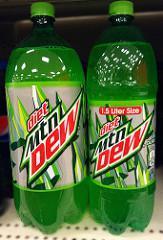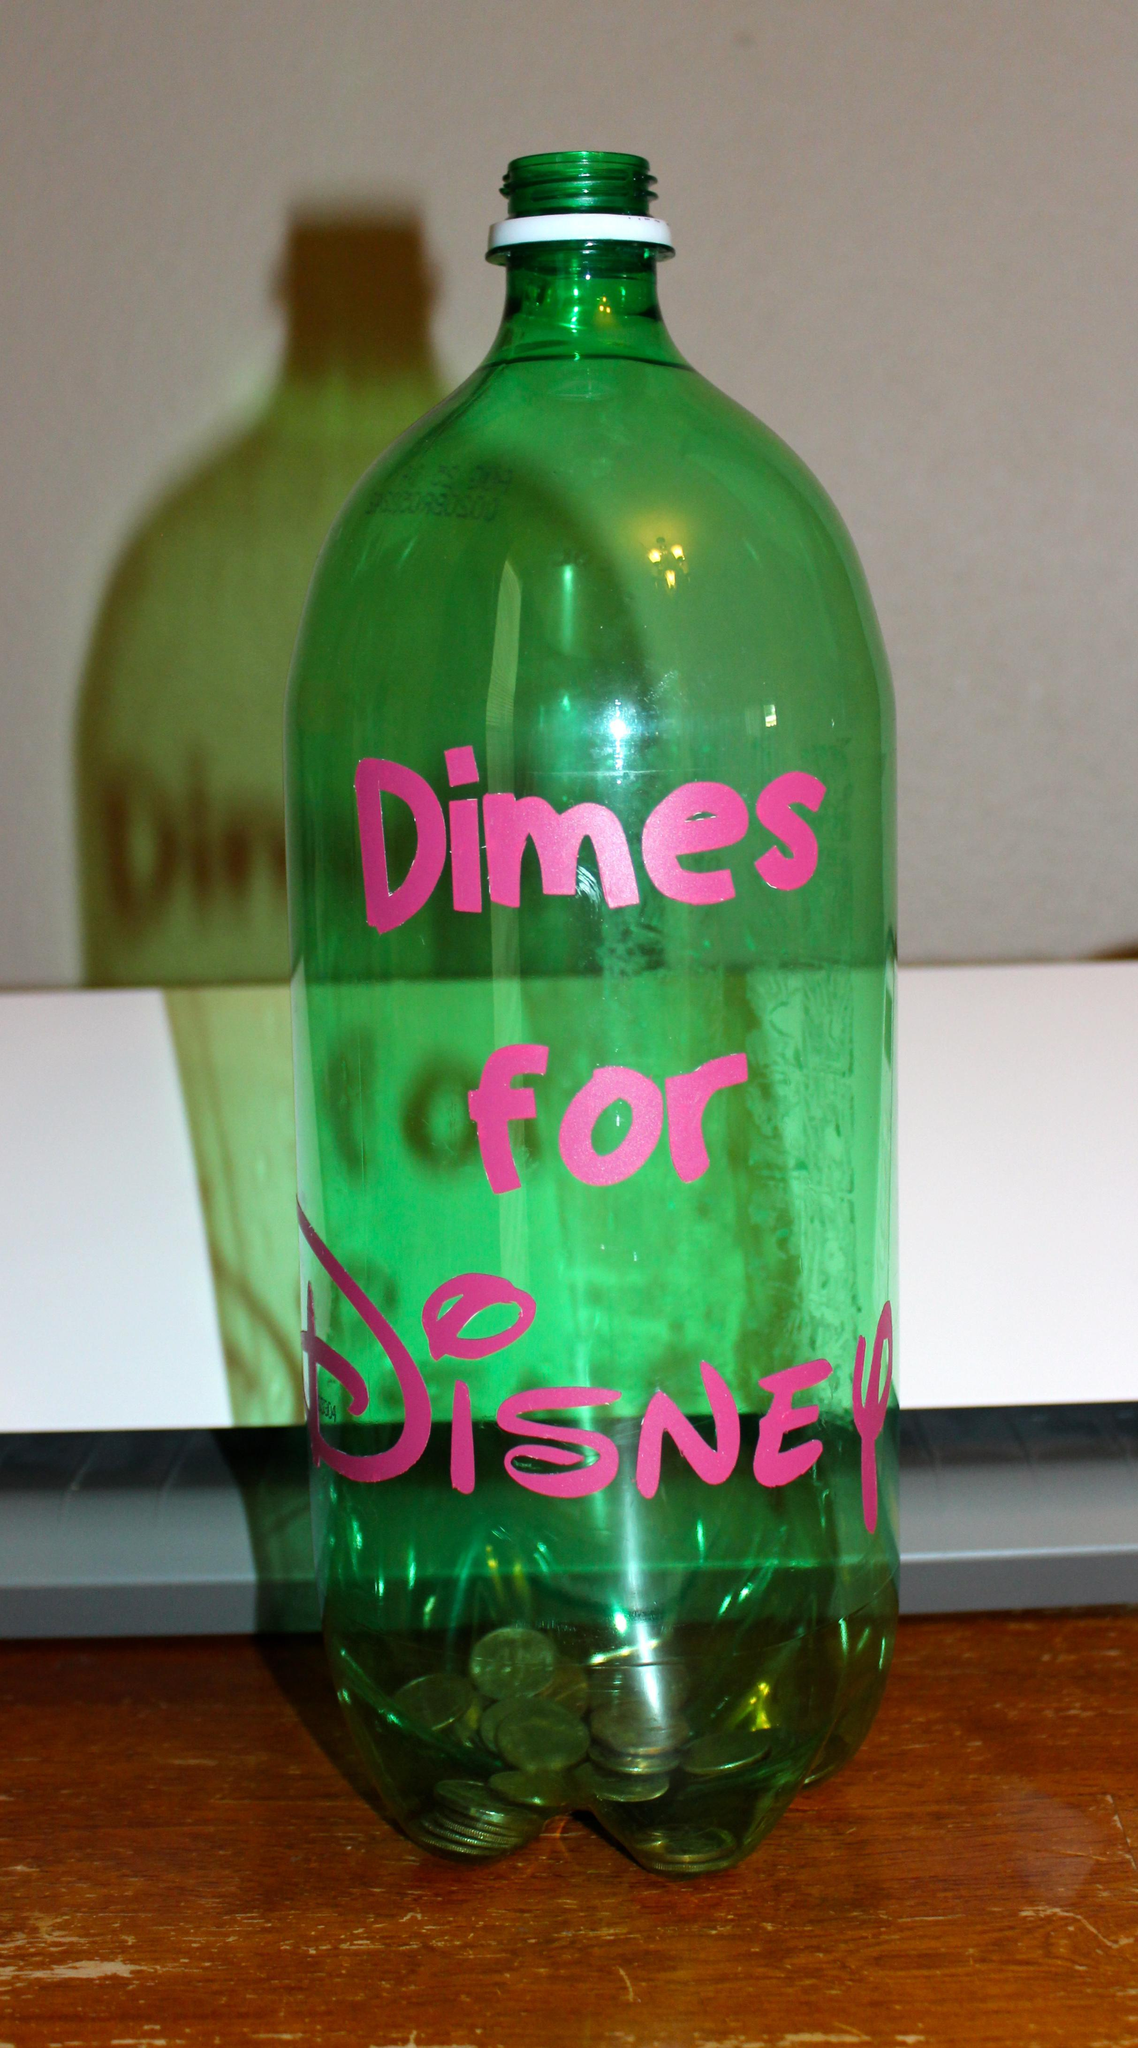The first image is the image on the left, the second image is the image on the right. Given the left and right images, does the statement "One of the bottles contains money bills." hold true? Answer yes or no. No. The first image is the image on the left, the second image is the image on the right. Given the left and right images, does the statement "Each image contains at least one green soda bottle, and the left image features a bottle with a label that includes jagged shapes and red letters." hold true? Answer yes or no. Yes. 